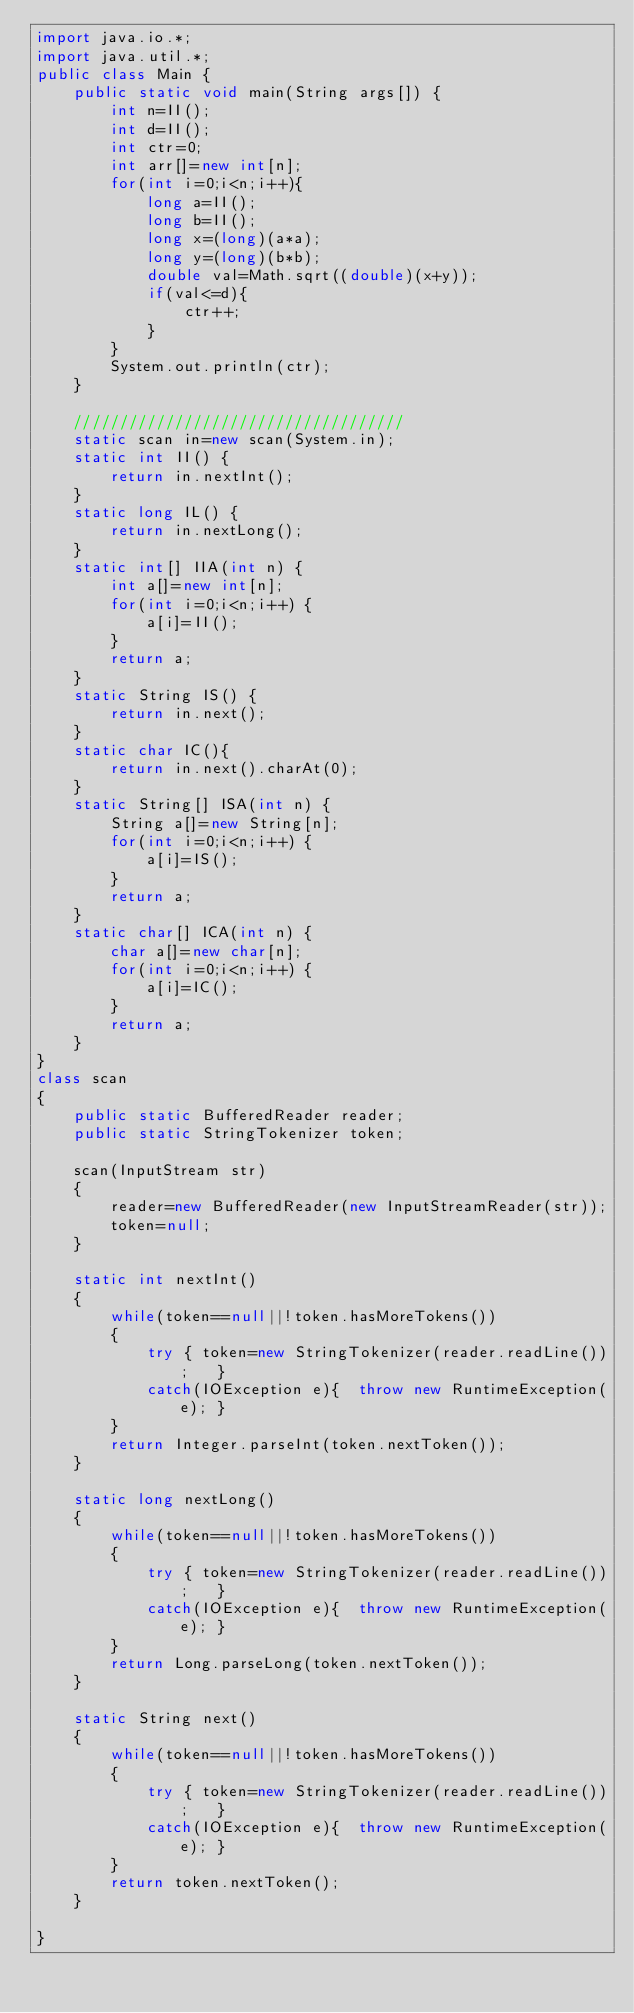Convert code to text. <code><loc_0><loc_0><loc_500><loc_500><_Java_>import java.io.*;
import java.util.*;
public class Main {        
    public static void main(String args[]) {
        int n=II();
        int d=II();
        int ctr=0;
        int arr[]=new int[n];
        for(int i=0;i<n;i++){
            long a=II();
            long b=II();
            long x=(long)(a*a);
            long y=(long)(b*b);
            double val=Math.sqrt((double)(x+y));
            if(val<=d){
                ctr++;
            }
        }
        System.out.println(ctr);
    }
    
    ////////////////////////////////////
    static scan in=new scan(System.in);
    static int II() {
        return in.nextInt();
    }
    static long IL() {
        return in.nextLong();
    }
    static int[] IIA(int n) {
        int a[]=new int[n];
        for(int i=0;i<n;i++) {
            a[i]=II();
        }
        return a;
    }
    static String IS() {
        return in.next();
    }
    static char IC(){
        return in.next().charAt(0);
    }
    static String[] ISA(int n) {
        String a[]=new String[n];
        for(int i=0;i<n;i++) {
            a[i]=IS();
        }
        return a;
    }
    static char[] ICA(int n) {
        char a[]=new char[n];
        for(int i=0;i<n;i++) {
            a[i]=IC();
        }
        return a;
    }
}
class scan
{
    public static BufferedReader reader;
    public static StringTokenizer token;

    scan(InputStream str)
    {
        reader=new BufferedReader(new InputStreamReader(str));
        token=null;
    }

    static int nextInt()
    {
        while(token==null||!token.hasMoreTokens())
        {
            try { token=new StringTokenizer(reader.readLine());   }
            catch(IOException e){  throw new RuntimeException(e); }
        }
        return Integer.parseInt(token.nextToken());
    }

    static long nextLong()
    {
        while(token==null||!token.hasMoreTokens())
        {
            try { token=new StringTokenizer(reader.readLine());   }
            catch(IOException e){  throw new RuntimeException(e); }
        }
        return Long.parseLong(token.nextToken());
    }

    static String next()
    {
        while(token==null||!token.hasMoreTokens())
        {
            try { token=new StringTokenizer(reader.readLine());   }
            catch(IOException e){  throw new RuntimeException(e); }
        }
        return token.nextToken();
    }

}</code> 